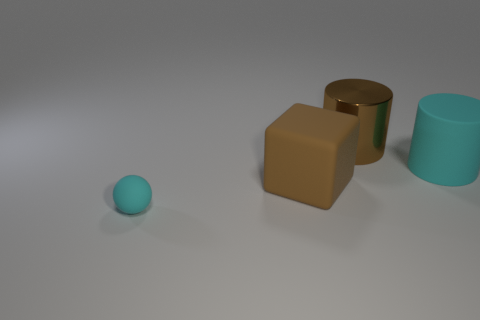Add 4 rubber spheres. How many objects exist? 8 Subtract all spheres. How many objects are left? 3 Add 3 large brown matte objects. How many large brown matte objects are left? 4 Add 4 cyan objects. How many cyan objects exist? 6 Subtract 0 cyan blocks. How many objects are left? 4 Subtract all big gray balls. Subtract all brown shiny things. How many objects are left? 3 